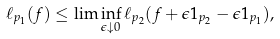<formula> <loc_0><loc_0><loc_500><loc_500>\ell _ { p _ { 1 } } ( f ) \leq \lim \inf _ { \epsilon \downarrow 0 } \ell _ { p _ { 2 } } ( f + \epsilon 1 _ { p _ { 2 } } - \epsilon 1 _ { p _ { 1 } } ) ,</formula> 